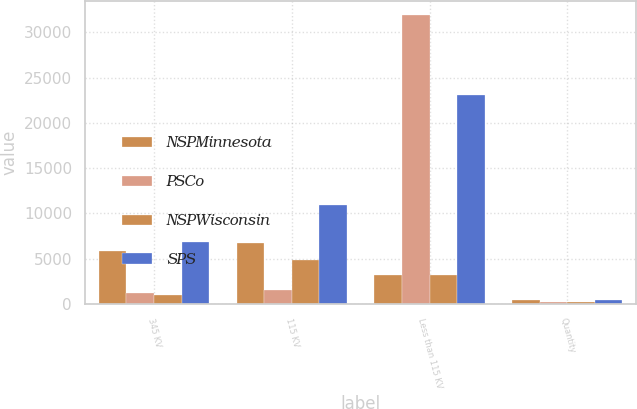Convert chart to OTSL. <chart><loc_0><loc_0><loc_500><loc_500><stacked_bar_chart><ecel><fcel>345 KV<fcel>115 KV<fcel>Less than 115 KV<fcel>Quantity<nl><fcel>NSPMinnesota<fcel>5852<fcel>6743<fcel>3199.5<fcel>372<nl><fcel>PSCo<fcel>1153<fcel>1529<fcel>31911<fcel>203<nl><fcel>NSPWisconsin<fcel>958<fcel>4870<fcel>3199.5<fcel>219<nl><fcel>SPS<fcel>6800<fcel>10966<fcel>23087<fcel>432<nl></chart> 